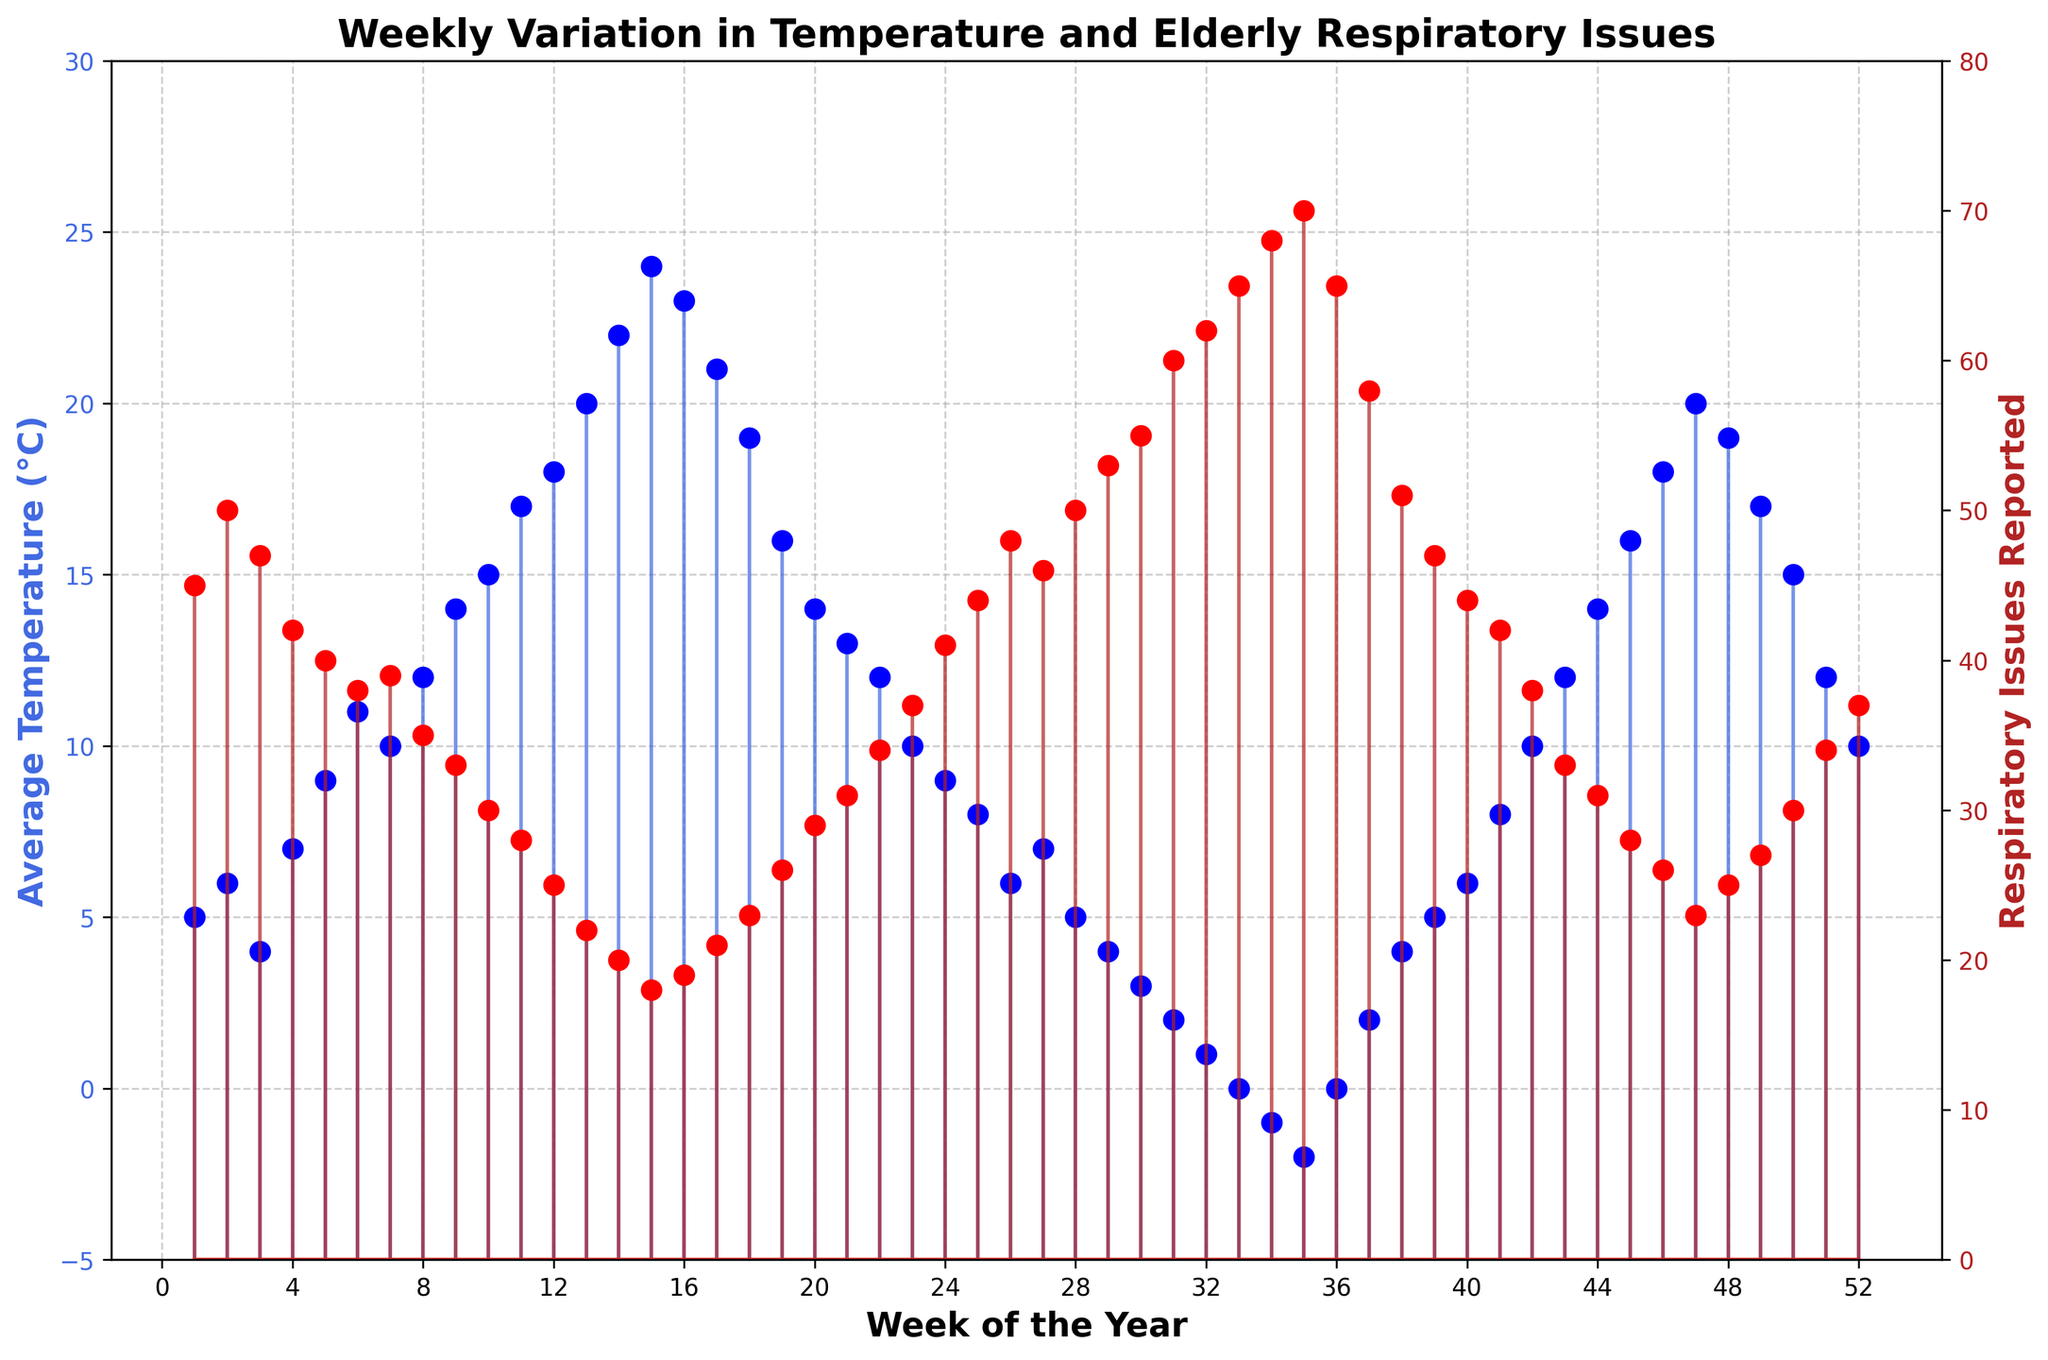What is the title of the plot? Look at the top center of the plot where the title is usually located. It reads "Weekly Variation in Temperature and Elderly Respiratory Issues".
Answer: Weekly Variation in Temperature and Elderly Respiratory Issues How does the weekly average temperature trend throughout the year? Observe the blue lines and markers representing temperature changes across the weeks on the left y-axis. The temperature generally increases from weeks 1 to 15, peaks around week 15, and then declines again until week 35 before slightly increasing towards the end of the year.
Answer: Increases, peaks, then decreases What is the general trend in respiratory issues as temperature decreases? Look at the red lines and markers indicating reported respiratory issues on the right y-axis. Notice that when temperatures drop (left y-axis), respiratory issues generally rise, especially noticeable in the colder weeks towards the end and start of the year.
Answer: Increases At what week does the average temperature peak, and what is the temperature? Find the highest point on the blue markers and lines on the left y-axis. The peak occurs around week 15, where the average temperature is 24°C.
Answer: Week 15, 24°C Which week reports the highest number of respiratory issues and how many were reported? Look for the highest point on the red markers and lines on the right y-axis. This occurs around week 35, where 70 respiratory issues were reported.
Answer: Week 35, 70 Compare the respiratory issues reported in weeks 1 and 52. How do they differ? Compare the red markers on the right y-axis for weeks 1 and 52. Week 1 reports 45 issues while week 52 reports 37 issues.
Answer: Week 1 has 8 more issues What is the average number of respiratory issues reported for the first 4 weeks of the year? Sum the respiratory issues for weeks 1 to 4 (45 + 50 + 47 + 42) and divide by 4. The average is 184/4 = 46.
Answer: 46 During which weeks does the temperature stay below 10°C and how does this affect respiratory issues? Observe the blue markers on the left y-axis and notice the weeks where the temperature is consistently below 10°C (weeks 1-5, 23-29, 30-34). Compare these intervals with the red markers on the right y-axis, showing that respiratory issues are typically higher during these periods.
Answer: Weeks 1-5, 23-29, 30-34, higher issues What is the difference in average temperature between week 8 and week 43? Look at the average temperatures for week 8 (12°C) and week 43 (14°C). Subtract the smaller value from the larger one: 14 - 12 = 2°C.
Answer: 2°C 